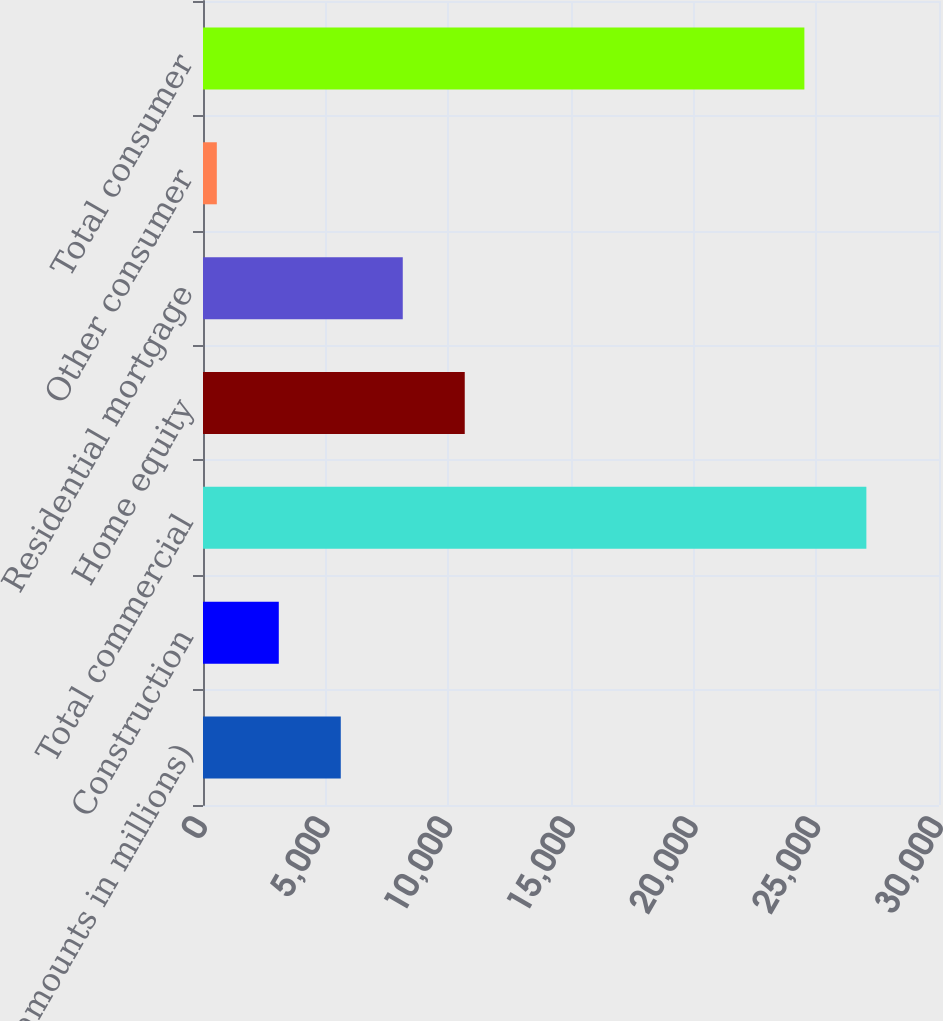Convert chart to OTSL. <chart><loc_0><loc_0><loc_500><loc_500><bar_chart><fcel>(dollar amounts in millions)<fcel>Construction<fcel>Total commercial<fcel>Home equity<fcel>Residential mortgage<fcel>Other consumer<fcel>Total consumer<nl><fcel>5616<fcel>3089.5<fcel>27039.5<fcel>10669<fcel>8142.5<fcel>563<fcel>24513<nl></chart> 